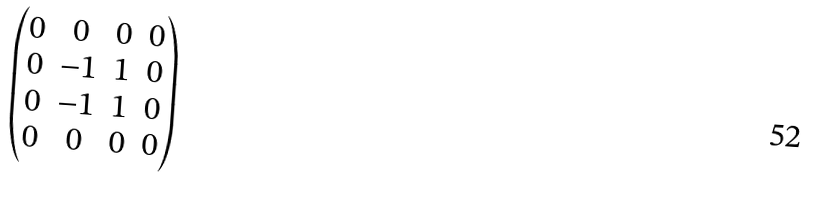<formula> <loc_0><loc_0><loc_500><loc_500>\begin{pmatrix} 0 & 0 & 0 & 0 \\ 0 & - 1 & 1 & 0 \\ 0 & - 1 & 1 & 0 \\ 0 & 0 & 0 & 0 \\ \end{pmatrix}</formula> 